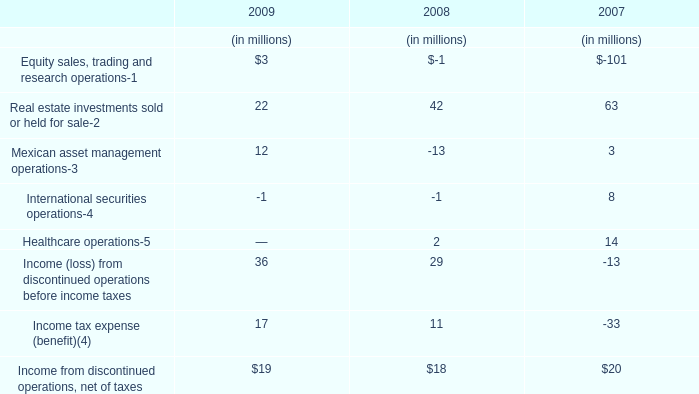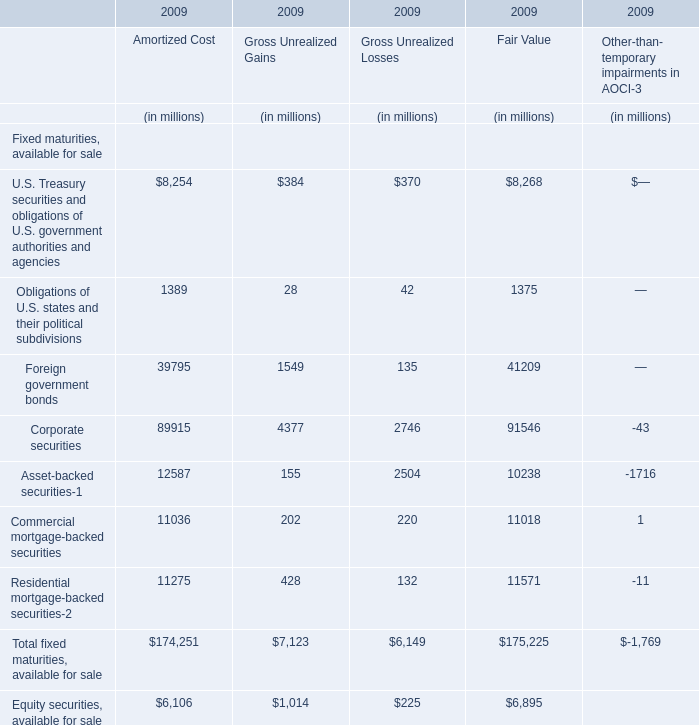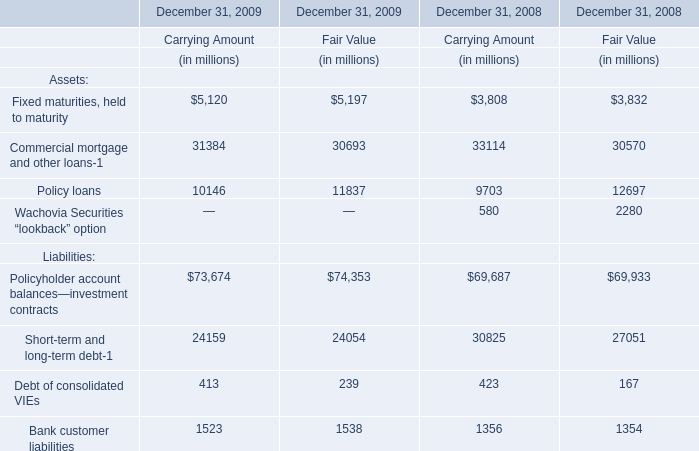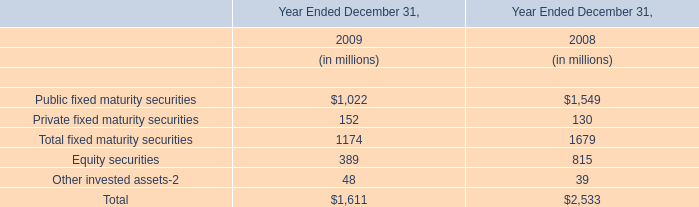What will Income tax expense (benefit)(4) be like in 2010 if it develops with the same increasing rate as current? (in million) 
Computations: ((((17 - 11) / 11) + 1) * 17)
Answer: 26.27273. 